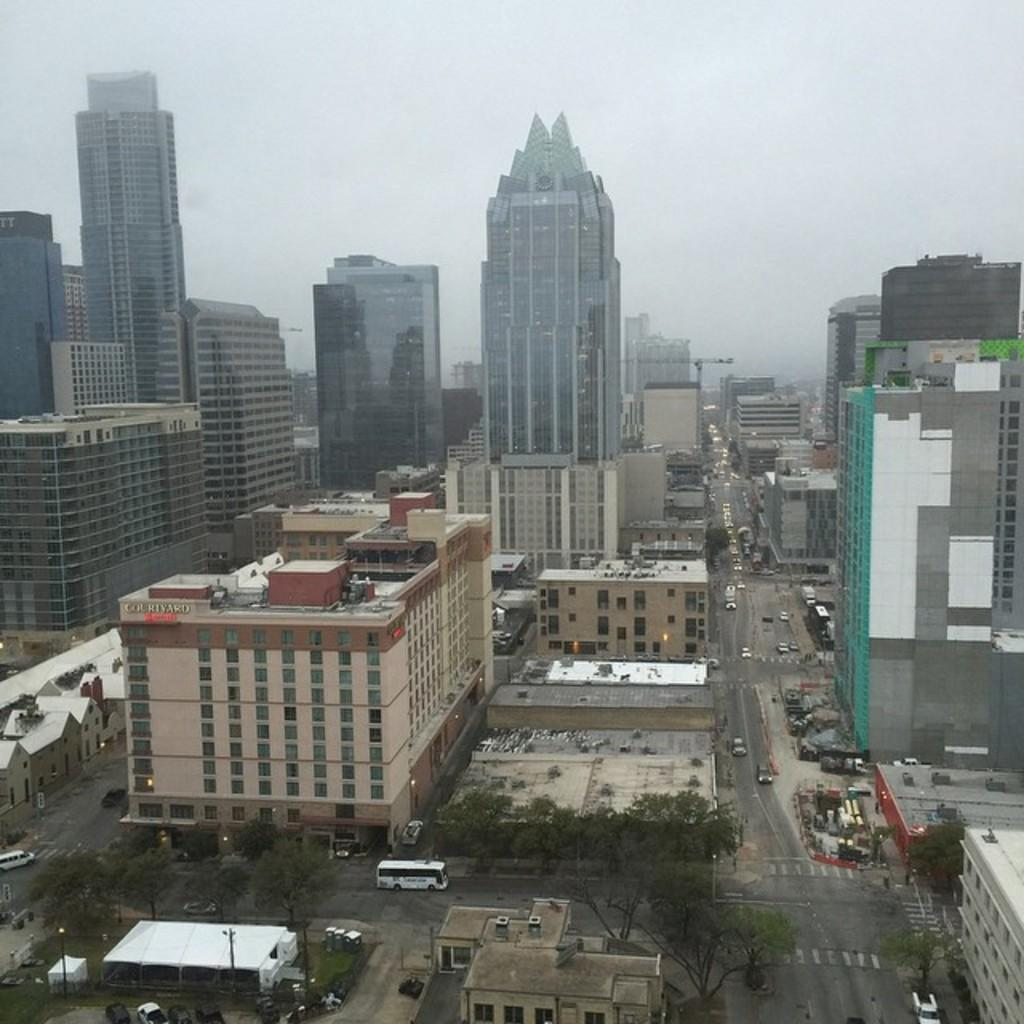What is happening on the road in the image? There are many vehicles moving on the road in the image. What type of structures can be seen in the image? There are buildings visible in the image. What is the perspective of the image? The image is an aerial view of a city. What else can be seen in the image besides the vehicles and buildings? The sky is visible in the image. What type of cabbage is being used to play volleyball in the image? There is no cabbage or volleyball present in the image. How much sugar is visible in the image? There is no sugar visible in the image. 